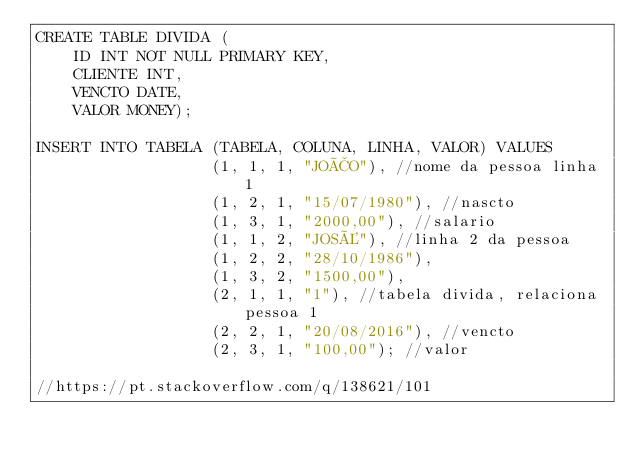<code> <loc_0><loc_0><loc_500><loc_500><_SQL_>CREATE TABLE DIVIDA (
    ID INT NOT NULL PRIMARY KEY,
    CLIENTE INT,
    VENCTO DATE,
    VALOR MONEY);

INSERT INTO TABELA (TABELA, COLUNA, LINHA, VALOR) VALUES
                   (1, 1, 1, "JOÃO"), //nome da pessoa linha 1
                   (1, 2, 1, "15/07/1980"), //nascto
                   (1, 3, 1, "2000,00"), //salario
                   (1, 1, 2, "JOSÉ"), //linha 2 da pessoa
                   (1, 2, 2, "28/10/1986"),
                   (1, 3, 2, "1500,00"),
                   (2, 1, 1, "1"), //tabela divida, relaciona pessoa 1
                   (2, 2, 1, "20/08/2016"), //vencto
                   (2, 3, 1, "100,00"); //valor
                   
//https://pt.stackoverflow.com/q/138621/101
</code> 